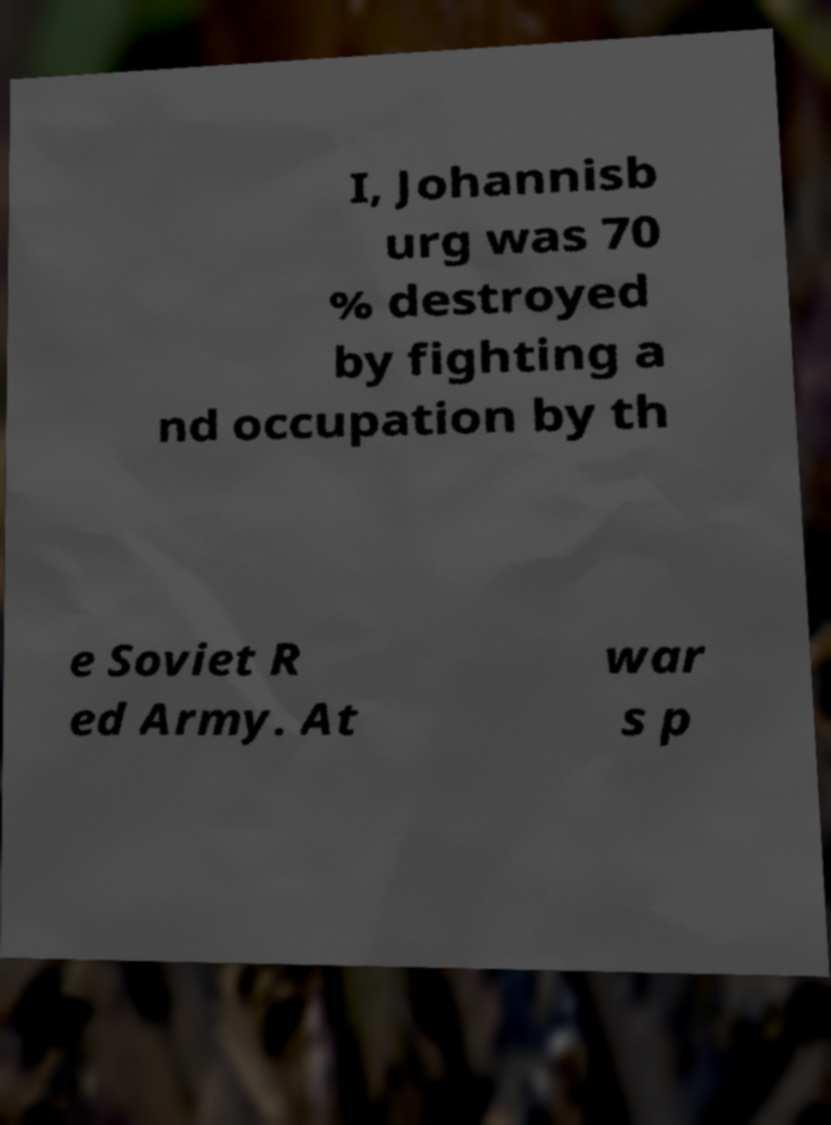Please identify and transcribe the text found in this image. I, Johannisb urg was 70 % destroyed by fighting a nd occupation by th e Soviet R ed Army. At war s p 